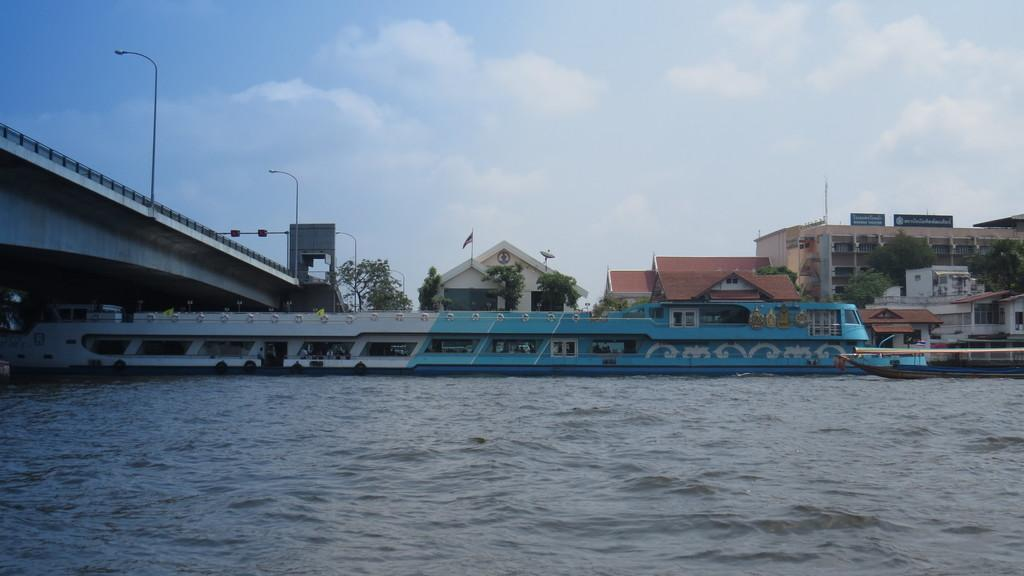What is the main subject of the image? The main subject of the image is a boat. Where is the boat located in the image? The boat is in the water. What other elements can be seen in the image? There are many trees, buildings, a bridge, and a light pole in the image. What is the condition of the sky in the image? The sky is cloudy in the image. Can you see any clovers growing near the boat in the image? There are no clovers visible in the image. Is there a fire burning near the boat in the image? There is no fire present in the image. 